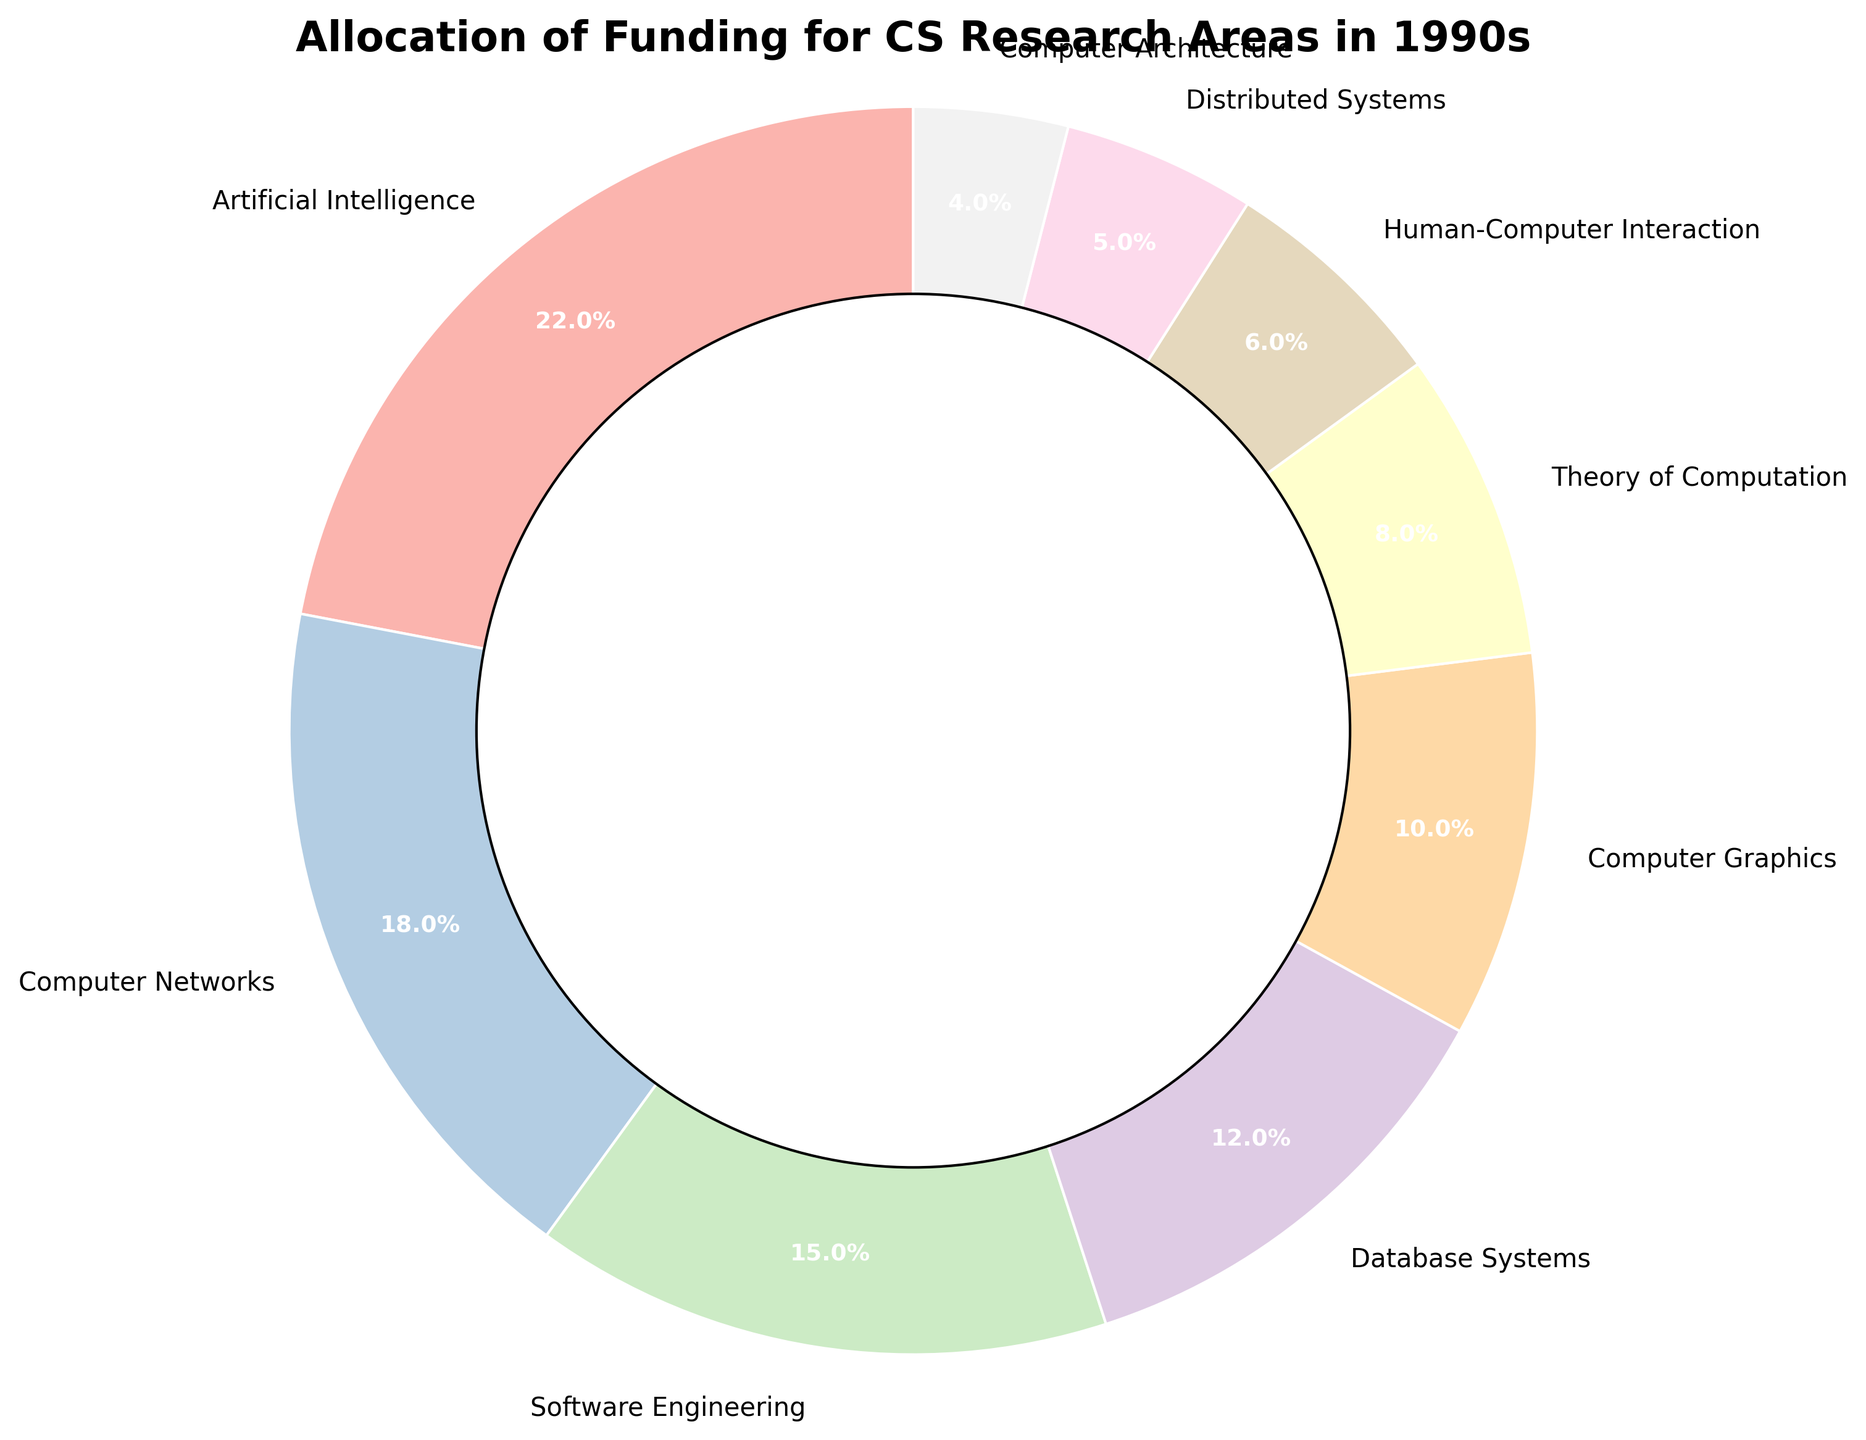What area received the highest percentage of funding? The slice for "Artificial Intelligence" is the largest and has the highest value, 22%.
Answer: Artificial Intelligence How much more funding did Computer Networks receive compared to Computer Architecture? Subtract the percentage for Computer Architecture (4%) from Computer Networks (18%). 18% - 4% = 14%.
Answer: 14% Which two areas received the smallest percentages of funding, and what are their combined percentages? The areas "Distributed Systems" and "Computer Architecture" have the smallest slices with 5% and 4%, respectively. Add them together: 5% + 4% = 9%.
Answer: Distributed Systems and Computer Architecture, 9% How does the funding for Human-Computer Interaction compare to that for Database Systems? Human-Computer Interaction received 6% while Database Systems received 12%. Compare the values: 6% < 12%.
Answer: Less What is the total percentage of funding allocated to Artificial Intelligence, Computer Networks, and Software Engineering combined? Add the percentages for Artificial Intelligence (22%), Computer Networks (18%), and Software Engineering (15%): 22% + 18% + 15% = 55%.
Answer: 55% How many areas received more than 10% of the funding? Identify the slices with more than 10%: Artificial Intelligence (22%), Computer Networks (18%), Software Engineering (15%), and Database Systems (12%). Count them: 4 areas.
Answer: 4 Which area received the closest funding percentage to Computer Graphics? Identify the percentages for all areas and compare to 10% for Computer Graphics. Theory of Computation has 8%, closest to 10%.
Answer: Theory of Computation What is the difference in funding between the highest and lowest-funded areas? Subtract the percentage of the lowest-funded area, Computer Architecture (4%), from the highest-funded area, Artificial Intelligence (22%): 22% - 4% = 18%.
Answer: 18% What is the average percentage of funding allocated per research area? Sum all percentages (22 + 18 + 15 + 12 + 10 + 8 + 6 + 5 + 4 = 100). Divide by the number of areas (9): 100 / 9 ≈ 11.11%.
Answer: 11.11% Which area, between Software Engineering and Database Systems, received less funding? Compare the slices for Software Engineering (15%) and Database Systems (12%): 15% > 12%.
Answer: Database Systems 